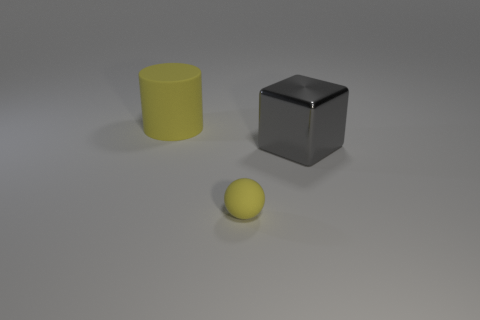Is the big matte object the same shape as the small yellow matte object? No, they are not the same shape. The larger, matte object is a cube, characterized by its six square faces, edges of equal length, and 90-degree angles. The smaller, yellow matte object, however, is a sphere, which is perfectly symmetrical and has no edges or vertices. 